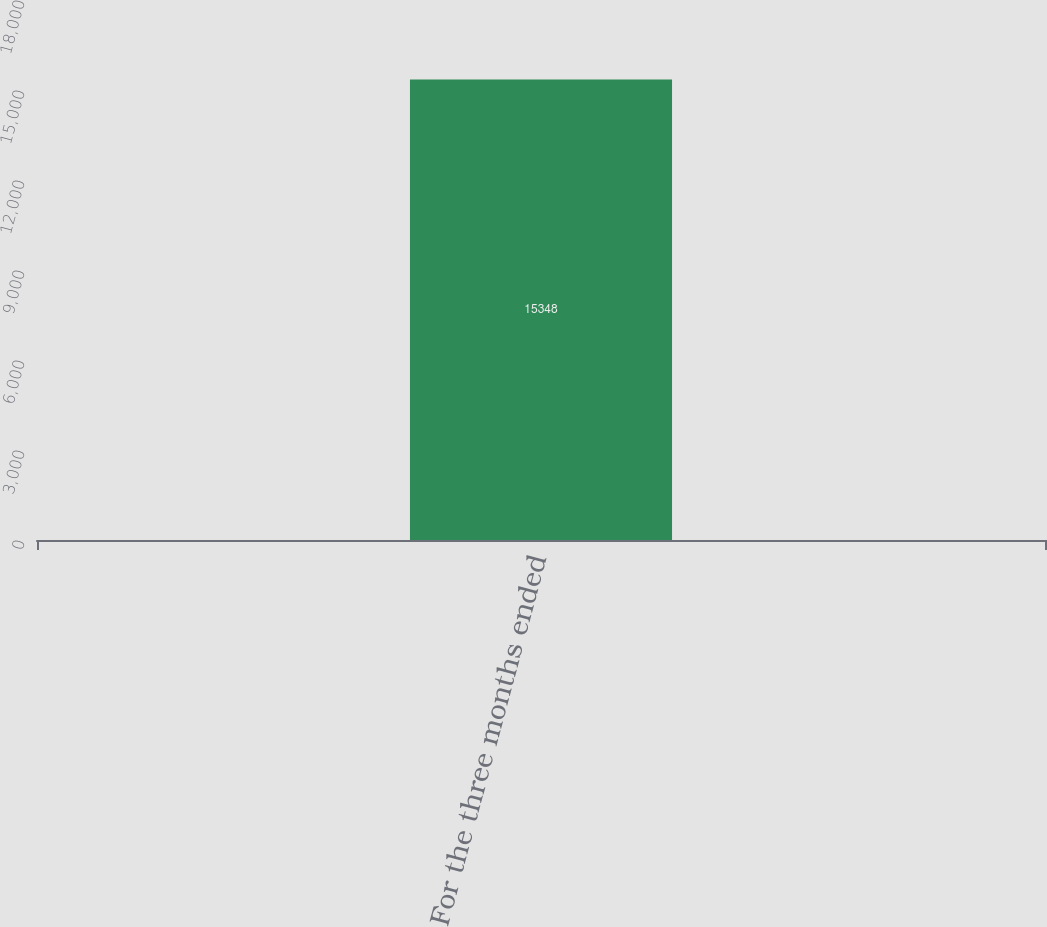Convert chart. <chart><loc_0><loc_0><loc_500><loc_500><bar_chart><fcel>For the three months ended<nl><fcel>15348<nl></chart> 